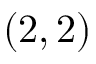Convert formula to latex. <formula><loc_0><loc_0><loc_500><loc_500>( 2 , 2 )</formula> 